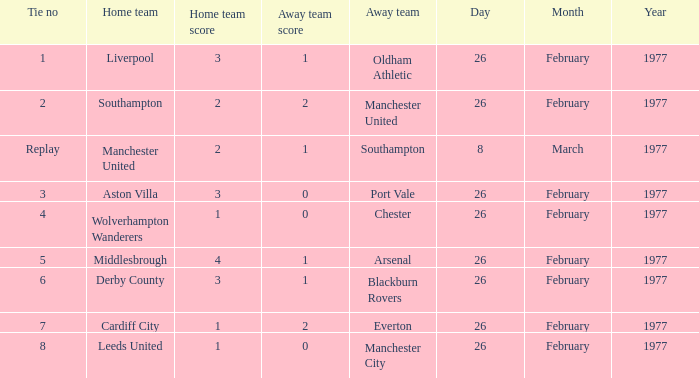What date was Chester the away team? 26 February 1977. 